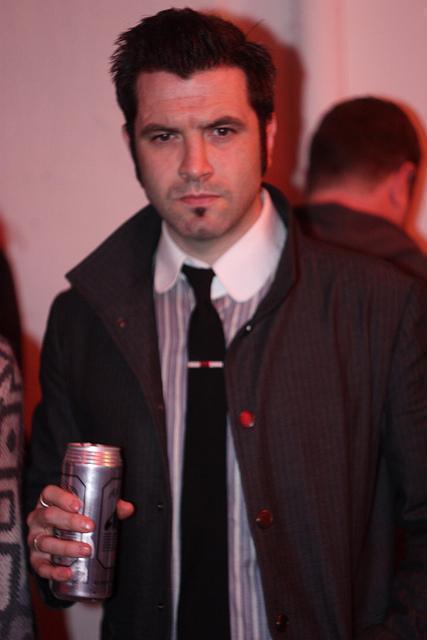How is the man holding the can feeling?
Select the accurate answer and provide explanation: 'Answer: answer
Rationale: rationale.'
Options: Friendly, happy, amused, angry. Answer: angry.
Rationale: The man is pouting. 